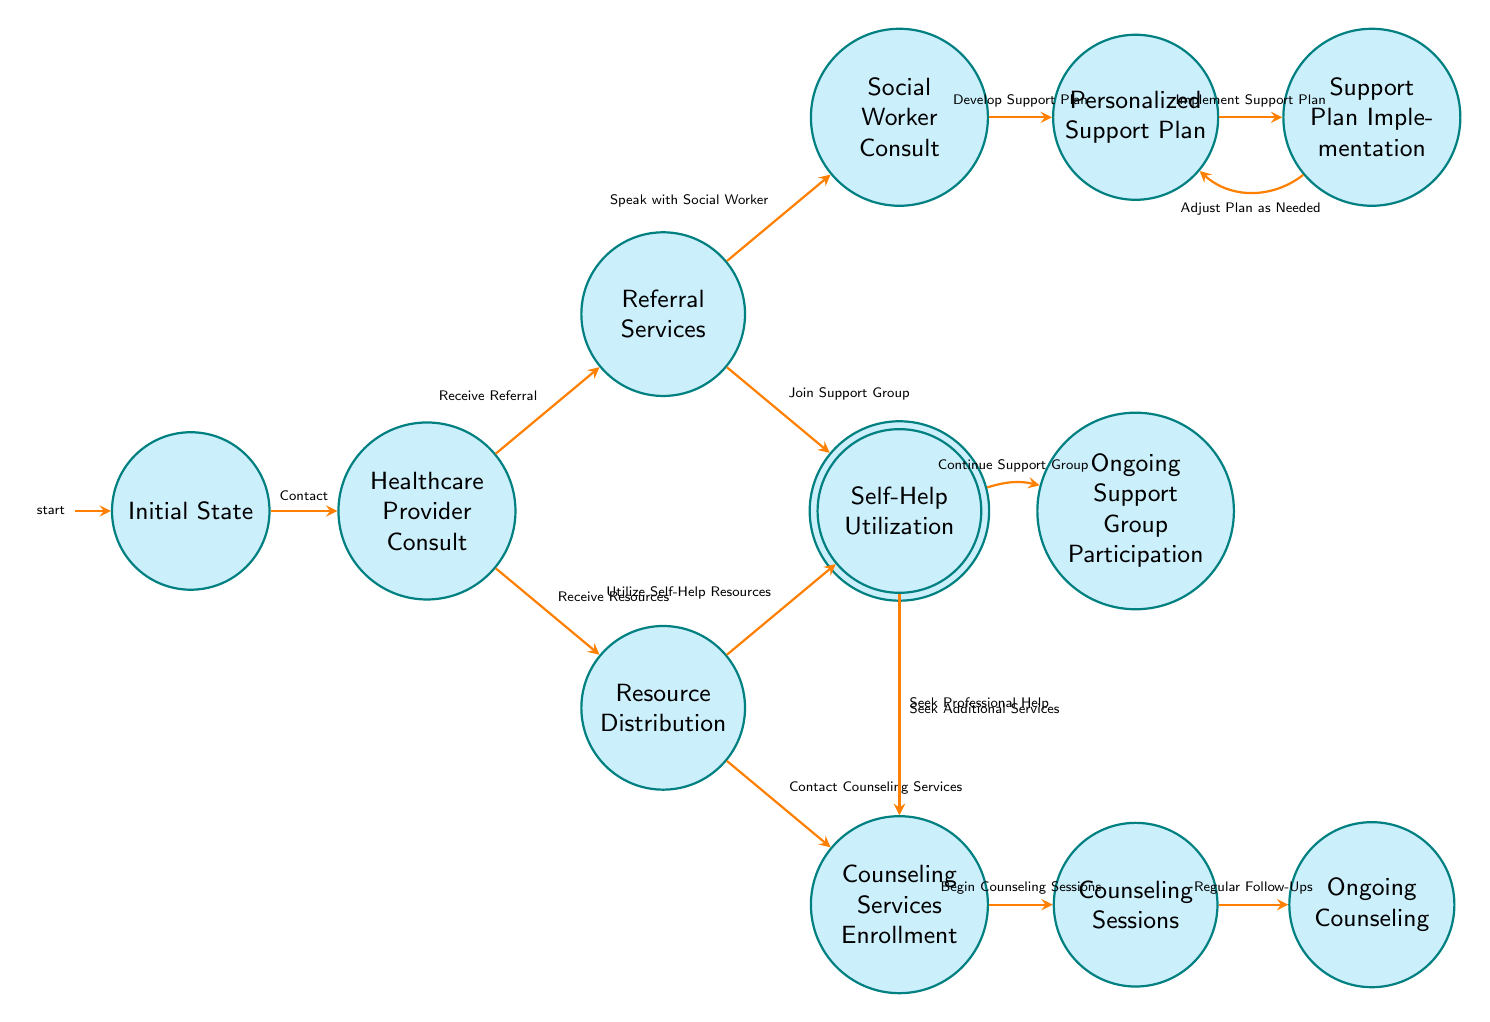What is the initial state in this diagram? The initial state is explicitly labeled as "Initial State." It is the starting point from which families begin their journey to seek emotional support.
Answer: Initial State How many nodes are in the diagram? To find the number of nodes, we count them in the diagram: Initial State, Healthcare Provider Consult, Referral Services, Resource Distribution, Social Worker Consult, Support Group Participation, Self-Help Utilization, Counseling Services Enrollment, Personalized Support Plan, Counseling Sessions, Ongoing Counseling, Support Plan Implementation, and Ongoing Support Group Participation. This gives us a total of 13 nodes.
Answer: 13 What transition occurs after "Healthcare Provider Consult" if the family "Receives Referral"? The transition that occurs after receiving a referral is to "Referral Services." This is indicated in the diagram where the edge directed from "Healthcare Provider Consult" to "Referral Services" is labeled as such.
Answer: Referral Services What happens at the "Social Worker Consult" state? At the "Social Worker Consult" state, families can "Develop Support Plan" with a social worker. This is indicated as a unique transition leading forward from this state to the "Personalized Support Plan."
Answer: Develop Support Plan If a family participates in a support group and wants to seek more help, which state do they transition to? If a family participates in a support group and decides to seek additional services, they transition to "Counseling Services Enrollment." This is shown in the diagram under "Support Group Participation" with a directed edge labeled accordingly.
Answer: Counseling Services Enrollment How many transitions lead from "Resource Distribution"? From "Resource Distribution," there are two transitions: one to "Self-Help Utilization" and the other to "Counseling Services Enrollment." Thus, there are a total of two transitions leading from this state.
Answer: 2 What state follows "Counseling Services Enrollment"? The state that follows "Counseling Services Enrollment" is "Counseling Sessions." This follows directly in the diagram, where the flow indicates that upon enrollment, families begin counseling sessions thereafter.
Answer: Counseling Sessions What is the outcome of implementing a personalized support plan? The outcome of implementing a personalized support plan leads to the state labeled "Support Plan Implementation." This shows the transition from developing the support plan to the actual implementation phase.
Answer: Support Plan Implementation What is the final step of the emotional support navigation process? The final step of the emotional support navigation process is "Ongoing Counseling." This indicates that after attending counseling sessions, families continue to have regular follow-ups with their counselor, which is a vital aspect of ongoing emotional support.
Answer: Ongoing Counseling 